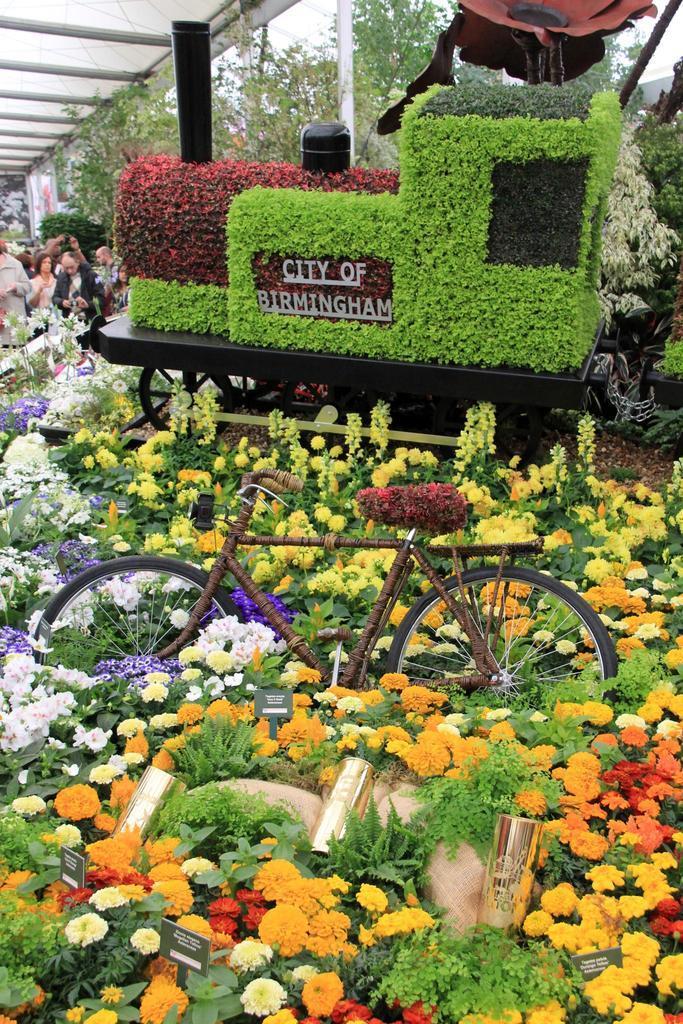How would you summarize this image in a sentence or two? There are flowers to the plant in the foreground area of the image, it seems like there are plants to the seat of a bicycle and on a vehicle, there is text on the vehicle. There are people, greenery, pole, roof and sky in the background. 